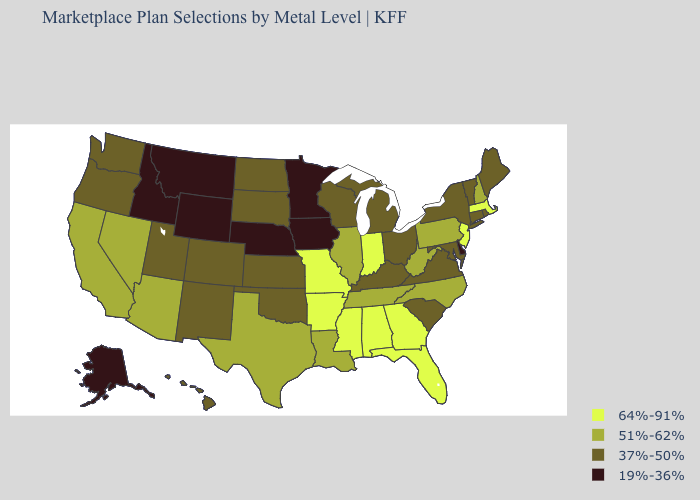Among the states that border Illinois , which have the highest value?
Answer briefly. Indiana, Missouri. Name the states that have a value in the range 64%-91%?
Write a very short answer. Alabama, Arkansas, Florida, Georgia, Indiana, Massachusetts, Mississippi, Missouri, New Jersey. Name the states that have a value in the range 37%-50%?
Short answer required. Colorado, Connecticut, Hawaii, Kansas, Kentucky, Maine, Maryland, Michigan, New Mexico, New York, North Dakota, Ohio, Oklahoma, Oregon, Rhode Island, South Carolina, South Dakota, Utah, Vermont, Virginia, Washington, Wisconsin. What is the lowest value in states that border Oregon?
Short answer required. 19%-36%. What is the highest value in the USA?
Concise answer only. 64%-91%. Does Missouri have the highest value in the MidWest?
Concise answer only. Yes. What is the value of North Carolina?
Concise answer only. 51%-62%. Does the first symbol in the legend represent the smallest category?
Give a very brief answer. No. Does Ohio have the highest value in the MidWest?
Quick response, please. No. Does Pennsylvania have a higher value than Vermont?
Quick response, please. Yes. Does the first symbol in the legend represent the smallest category?
Answer briefly. No. Among the states that border New Jersey , does Pennsylvania have the highest value?
Short answer required. Yes. Among the states that border Kansas , which have the highest value?
Write a very short answer. Missouri. Is the legend a continuous bar?
Write a very short answer. No. What is the value of New Hampshire?
Quick response, please. 51%-62%. 